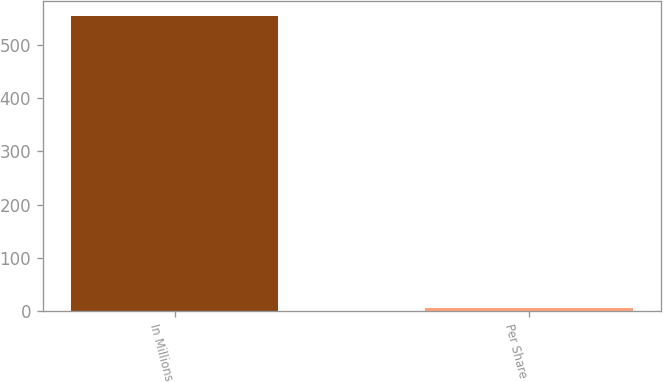Convert chart. <chart><loc_0><loc_0><loc_500><loc_500><bar_chart><fcel>In Millions<fcel>Per Share<nl><fcel>554.5<fcel>6.02<nl></chart> 